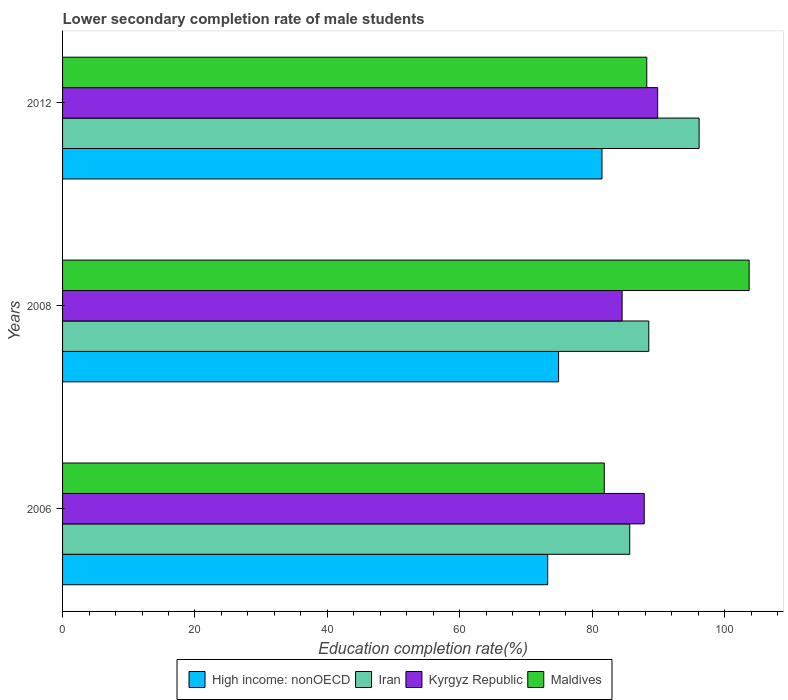How many groups of bars are there?
Ensure brevity in your answer.  3. Are the number of bars per tick equal to the number of legend labels?
Keep it short and to the point. Yes. Are the number of bars on each tick of the Y-axis equal?
Ensure brevity in your answer.  Yes. How many bars are there on the 1st tick from the top?
Your answer should be very brief. 4. What is the lower secondary completion rate of male students in Kyrgyz Republic in 2012?
Ensure brevity in your answer.  89.88. Across all years, what is the maximum lower secondary completion rate of male students in Iran?
Your answer should be compact. 96.14. Across all years, what is the minimum lower secondary completion rate of male students in Iran?
Make the answer very short. 85.66. What is the total lower secondary completion rate of male students in Kyrgyz Republic in the graph?
Your answer should be very brief. 262.25. What is the difference between the lower secondary completion rate of male students in Iran in 2008 and that in 2012?
Offer a terse response. -7.6. What is the difference between the lower secondary completion rate of male students in Kyrgyz Republic in 2008 and the lower secondary completion rate of male students in Maldives in 2012?
Keep it short and to the point. -3.72. What is the average lower secondary completion rate of male students in High income: nonOECD per year?
Your answer should be compact. 76.55. In the year 2006, what is the difference between the lower secondary completion rate of male students in Kyrgyz Republic and lower secondary completion rate of male students in Iran?
Make the answer very short. 2.19. What is the ratio of the lower secondary completion rate of male students in High income: nonOECD in 2008 to that in 2012?
Your response must be concise. 0.92. Is the difference between the lower secondary completion rate of male students in Kyrgyz Republic in 2006 and 2008 greater than the difference between the lower secondary completion rate of male students in Iran in 2006 and 2008?
Your answer should be compact. Yes. What is the difference between the highest and the second highest lower secondary completion rate of male students in Maldives?
Offer a very short reply. 15.46. What is the difference between the highest and the lowest lower secondary completion rate of male students in Iran?
Your answer should be very brief. 10.48. Is it the case that in every year, the sum of the lower secondary completion rate of male students in Iran and lower secondary completion rate of male students in High income: nonOECD is greater than the sum of lower secondary completion rate of male students in Maldives and lower secondary completion rate of male students in Kyrgyz Republic?
Your answer should be compact. No. What does the 3rd bar from the top in 2012 represents?
Ensure brevity in your answer.  Iran. What does the 2nd bar from the bottom in 2012 represents?
Offer a very short reply. Iran. How many years are there in the graph?
Make the answer very short. 3. Are the values on the major ticks of X-axis written in scientific E-notation?
Provide a succinct answer. No. How many legend labels are there?
Your response must be concise. 4. How are the legend labels stacked?
Provide a short and direct response. Horizontal. What is the title of the graph?
Ensure brevity in your answer.  Lower secondary completion rate of male students. What is the label or title of the X-axis?
Your answer should be very brief. Education completion rate(%). What is the label or title of the Y-axis?
Ensure brevity in your answer.  Years. What is the Education completion rate(%) in High income: nonOECD in 2006?
Provide a succinct answer. 73.27. What is the Education completion rate(%) in Iran in 2006?
Make the answer very short. 85.66. What is the Education completion rate(%) of Kyrgyz Republic in 2006?
Provide a short and direct response. 87.85. What is the Education completion rate(%) in Maldives in 2006?
Give a very brief answer. 81.82. What is the Education completion rate(%) in High income: nonOECD in 2008?
Make the answer very short. 74.92. What is the Education completion rate(%) in Iran in 2008?
Give a very brief answer. 88.54. What is the Education completion rate(%) in Kyrgyz Republic in 2008?
Offer a terse response. 84.51. What is the Education completion rate(%) in Maldives in 2008?
Keep it short and to the point. 103.7. What is the Education completion rate(%) in High income: nonOECD in 2012?
Your answer should be very brief. 81.47. What is the Education completion rate(%) in Iran in 2012?
Provide a succinct answer. 96.14. What is the Education completion rate(%) of Kyrgyz Republic in 2012?
Make the answer very short. 89.88. What is the Education completion rate(%) in Maldives in 2012?
Provide a short and direct response. 88.24. Across all years, what is the maximum Education completion rate(%) in High income: nonOECD?
Provide a succinct answer. 81.47. Across all years, what is the maximum Education completion rate(%) of Iran?
Keep it short and to the point. 96.14. Across all years, what is the maximum Education completion rate(%) of Kyrgyz Republic?
Your answer should be compact. 89.88. Across all years, what is the maximum Education completion rate(%) in Maldives?
Provide a succinct answer. 103.7. Across all years, what is the minimum Education completion rate(%) of High income: nonOECD?
Your answer should be compact. 73.27. Across all years, what is the minimum Education completion rate(%) in Iran?
Keep it short and to the point. 85.66. Across all years, what is the minimum Education completion rate(%) in Kyrgyz Republic?
Offer a terse response. 84.51. Across all years, what is the minimum Education completion rate(%) in Maldives?
Keep it short and to the point. 81.82. What is the total Education completion rate(%) of High income: nonOECD in the graph?
Provide a short and direct response. 229.66. What is the total Education completion rate(%) in Iran in the graph?
Offer a very short reply. 270.35. What is the total Education completion rate(%) of Kyrgyz Republic in the graph?
Ensure brevity in your answer.  262.25. What is the total Education completion rate(%) in Maldives in the graph?
Your answer should be very brief. 273.75. What is the difference between the Education completion rate(%) in High income: nonOECD in 2006 and that in 2008?
Keep it short and to the point. -1.65. What is the difference between the Education completion rate(%) in Iran in 2006 and that in 2008?
Your answer should be compact. -2.88. What is the difference between the Education completion rate(%) of Kyrgyz Republic in 2006 and that in 2008?
Your answer should be compact. 3.34. What is the difference between the Education completion rate(%) of Maldives in 2006 and that in 2008?
Provide a short and direct response. -21.89. What is the difference between the Education completion rate(%) in High income: nonOECD in 2006 and that in 2012?
Ensure brevity in your answer.  -8.2. What is the difference between the Education completion rate(%) in Iran in 2006 and that in 2012?
Give a very brief answer. -10.48. What is the difference between the Education completion rate(%) of Kyrgyz Republic in 2006 and that in 2012?
Provide a short and direct response. -2.03. What is the difference between the Education completion rate(%) in Maldives in 2006 and that in 2012?
Keep it short and to the point. -6.42. What is the difference between the Education completion rate(%) in High income: nonOECD in 2008 and that in 2012?
Offer a terse response. -6.55. What is the difference between the Education completion rate(%) in Iran in 2008 and that in 2012?
Offer a terse response. -7.6. What is the difference between the Education completion rate(%) of Kyrgyz Republic in 2008 and that in 2012?
Give a very brief answer. -5.37. What is the difference between the Education completion rate(%) of Maldives in 2008 and that in 2012?
Keep it short and to the point. 15.46. What is the difference between the Education completion rate(%) of High income: nonOECD in 2006 and the Education completion rate(%) of Iran in 2008?
Provide a succinct answer. -15.27. What is the difference between the Education completion rate(%) of High income: nonOECD in 2006 and the Education completion rate(%) of Kyrgyz Republic in 2008?
Give a very brief answer. -11.24. What is the difference between the Education completion rate(%) in High income: nonOECD in 2006 and the Education completion rate(%) in Maldives in 2008?
Provide a short and direct response. -30.43. What is the difference between the Education completion rate(%) in Iran in 2006 and the Education completion rate(%) in Kyrgyz Republic in 2008?
Ensure brevity in your answer.  1.15. What is the difference between the Education completion rate(%) in Iran in 2006 and the Education completion rate(%) in Maldives in 2008?
Provide a succinct answer. -18.04. What is the difference between the Education completion rate(%) of Kyrgyz Republic in 2006 and the Education completion rate(%) of Maldives in 2008?
Provide a short and direct response. -15.85. What is the difference between the Education completion rate(%) of High income: nonOECD in 2006 and the Education completion rate(%) of Iran in 2012?
Offer a very short reply. -22.87. What is the difference between the Education completion rate(%) of High income: nonOECD in 2006 and the Education completion rate(%) of Kyrgyz Republic in 2012?
Ensure brevity in your answer.  -16.61. What is the difference between the Education completion rate(%) in High income: nonOECD in 2006 and the Education completion rate(%) in Maldives in 2012?
Provide a short and direct response. -14.97. What is the difference between the Education completion rate(%) in Iran in 2006 and the Education completion rate(%) in Kyrgyz Republic in 2012?
Give a very brief answer. -4.22. What is the difference between the Education completion rate(%) in Iran in 2006 and the Education completion rate(%) in Maldives in 2012?
Offer a very short reply. -2.58. What is the difference between the Education completion rate(%) in Kyrgyz Republic in 2006 and the Education completion rate(%) in Maldives in 2012?
Keep it short and to the point. -0.39. What is the difference between the Education completion rate(%) in High income: nonOECD in 2008 and the Education completion rate(%) in Iran in 2012?
Keep it short and to the point. -21.22. What is the difference between the Education completion rate(%) in High income: nonOECD in 2008 and the Education completion rate(%) in Kyrgyz Republic in 2012?
Your answer should be compact. -14.96. What is the difference between the Education completion rate(%) of High income: nonOECD in 2008 and the Education completion rate(%) of Maldives in 2012?
Your answer should be compact. -13.32. What is the difference between the Education completion rate(%) in Iran in 2008 and the Education completion rate(%) in Kyrgyz Republic in 2012?
Offer a very short reply. -1.34. What is the difference between the Education completion rate(%) of Iran in 2008 and the Education completion rate(%) of Maldives in 2012?
Give a very brief answer. 0.31. What is the difference between the Education completion rate(%) of Kyrgyz Republic in 2008 and the Education completion rate(%) of Maldives in 2012?
Your response must be concise. -3.72. What is the average Education completion rate(%) in High income: nonOECD per year?
Your response must be concise. 76.55. What is the average Education completion rate(%) of Iran per year?
Offer a very short reply. 90.12. What is the average Education completion rate(%) in Kyrgyz Republic per year?
Provide a succinct answer. 87.42. What is the average Education completion rate(%) of Maldives per year?
Provide a succinct answer. 91.25. In the year 2006, what is the difference between the Education completion rate(%) in High income: nonOECD and Education completion rate(%) in Iran?
Your answer should be very brief. -12.39. In the year 2006, what is the difference between the Education completion rate(%) in High income: nonOECD and Education completion rate(%) in Kyrgyz Republic?
Keep it short and to the point. -14.58. In the year 2006, what is the difference between the Education completion rate(%) of High income: nonOECD and Education completion rate(%) of Maldives?
Provide a short and direct response. -8.55. In the year 2006, what is the difference between the Education completion rate(%) of Iran and Education completion rate(%) of Kyrgyz Republic?
Your answer should be very brief. -2.19. In the year 2006, what is the difference between the Education completion rate(%) of Iran and Education completion rate(%) of Maldives?
Give a very brief answer. 3.85. In the year 2006, what is the difference between the Education completion rate(%) of Kyrgyz Republic and Education completion rate(%) of Maldives?
Ensure brevity in your answer.  6.03. In the year 2008, what is the difference between the Education completion rate(%) of High income: nonOECD and Education completion rate(%) of Iran?
Ensure brevity in your answer.  -13.63. In the year 2008, what is the difference between the Education completion rate(%) in High income: nonOECD and Education completion rate(%) in Kyrgyz Republic?
Your response must be concise. -9.6. In the year 2008, what is the difference between the Education completion rate(%) in High income: nonOECD and Education completion rate(%) in Maldives?
Give a very brief answer. -28.78. In the year 2008, what is the difference between the Education completion rate(%) of Iran and Education completion rate(%) of Kyrgyz Republic?
Provide a short and direct response. 4.03. In the year 2008, what is the difference between the Education completion rate(%) of Iran and Education completion rate(%) of Maldives?
Provide a short and direct response. -15.16. In the year 2008, what is the difference between the Education completion rate(%) of Kyrgyz Republic and Education completion rate(%) of Maldives?
Provide a succinct answer. -19.19. In the year 2012, what is the difference between the Education completion rate(%) in High income: nonOECD and Education completion rate(%) in Iran?
Your answer should be very brief. -14.67. In the year 2012, what is the difference between the Education completion rate(%) in High income: nonOECD and Education completion rate(%) in Kyrgyz Republic?
Provide a succinct answer. -8.41. In the year 2012, what is the difference between the Education completion rate(%) in High income: nonOECD and Education completion rate(%) in Maldives?
Offer a very short reply. -6.77. In the year 2012, what is the difference between the Education completion rate(%) in Iran and Education completion rate(%) in Kyrgyz Republic?
Offer a terse response. 6.26. In the year 2012, what is the difference between the Education completion rate(%) in Iran and Education completion rate(%) in Maldives?
Keep it short and to the point. 7.9. In the year 2012, what is the difference between the Education completion rate(%) of Kyrgyz Republic and Education completion rate(%) of Maldives?
Provide a succinct answer. 1.64. What is the ratio of the Education completion rate(%) of Iran in 2006 to that in 2008?
Give a very brief answer. 0.97. What is the ratio of the Education completion rate(%) of Kyrgyz Republic in 2006 to that in 2008?
Make the answer very short. 1.04. What is the ratio of the Education completion rate(%) of Maldives in 2006 to that in 2008?
Give a very brief answer. 0.79. What is the ratio of the Education completion rate(%) in High income: nonOECD in 2006 to that in 2012?
Provide a succinct answer. 0.9. What is the ratio of the Education completion rate(%) in Iran in 2006 to that in 2012?
Make the answer very short. 0.89. What is the ratio of the Education completion rate(%) in Kyrgyz Republic in 2006 to that in 2012?
Provide a succinct answer. 0.98. What is the ratio of the Education completion rate(%) of Maldives in 2006 to that in 2012?
Provide a succinct answer. 0.93. What is the ratio of the Education completion rate(%) of High income: nonOECD in 2008 to that in 2012?
Your response must be concise. 0.92. What is the ratio of the Education completion rate(%) of Iran in 2008 to that in 2012?
Give a very brief answer. 0.92. What is the ratio of the Education completion rate(%) in Kyrgyz Republic in 2008 to that in 2012?
Give a very brief answer. 0.94. What is the ratio of the Education completion rate(%) in Maldives in 2008 to that in 2012?
Provide a short and direct response. 1.18. What is the difference between the highest and the second highest Education completion rate(%) of High income: nonOECD?
Your answer should be very brief. 6.55. What is the difference between the highest and the second highest Education completion rate(%) in Iran?
Keep it short and to the point. 7.6. What is the difference between the highest and the second highest Education completion rate(%) of Kyrgyz Republic?
Your response must be concise. 2.03. What is the difference between the highest and the second highest Education completion rate(%) of Maldives?
Offer a very short reply. 15.46. What is the difference between the highest and the lowest Education completion rate(%) in High income: nonOECD?
Keep it short and to the point. 8.2. What is the difference between the highest and the lowest Education completion rate(%) of Iran?
Keep it short and to the point. 10.48. What is the difference between the highest and the lowest Education completion rate(%) in Kyrgyz Republic?
Make the answer very short. 5.37. What is the difference between the highest and the lowest Education completion rate(%) of Maldives?
Keep it short and to the point. 21.89. 